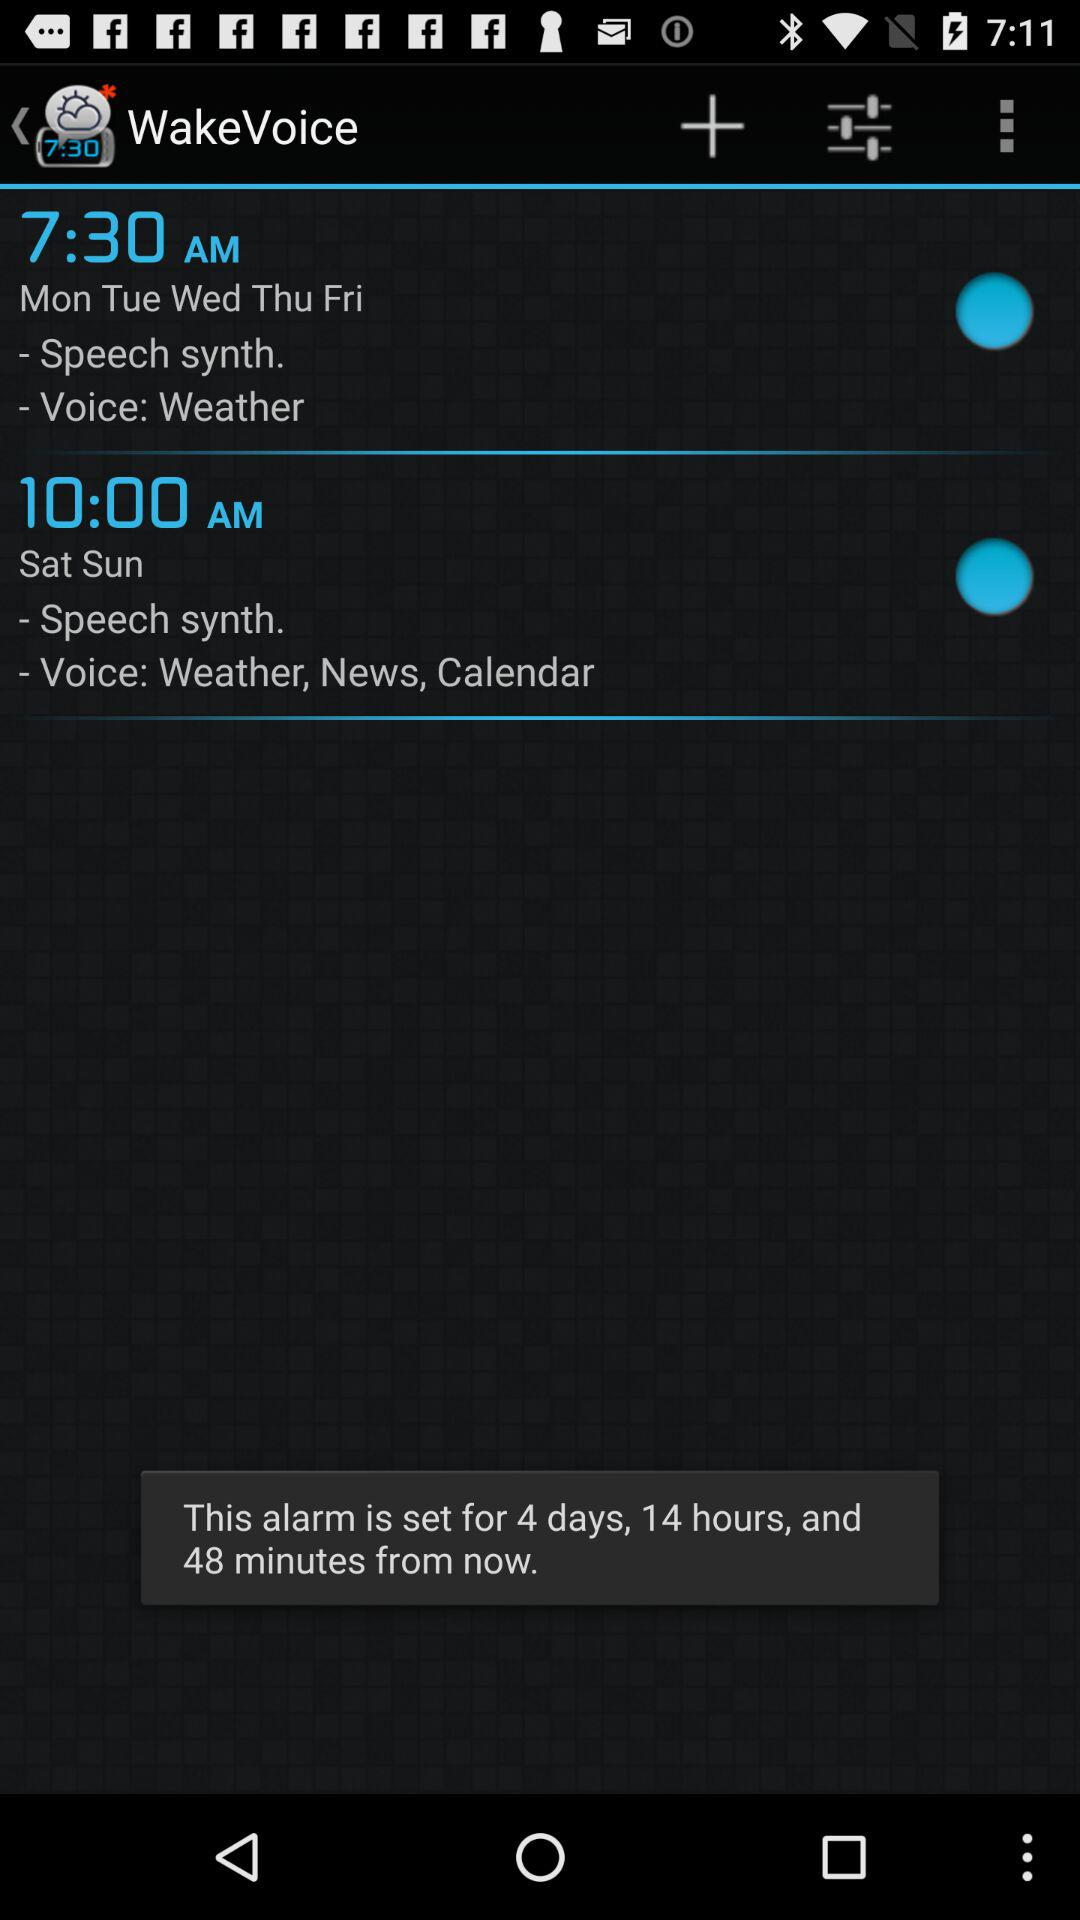What is the application name? The application name is "WakeVoice". 